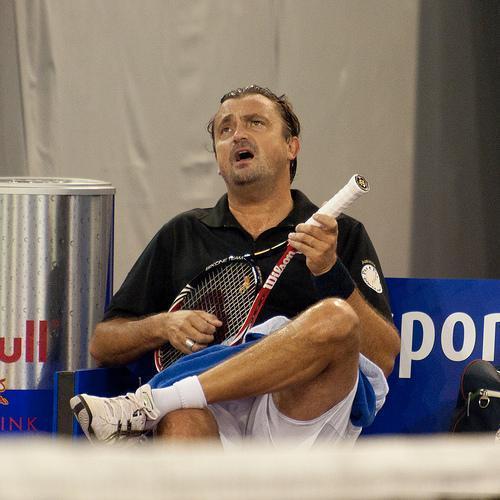How many people are there?
Give a very brief answer. 1. 